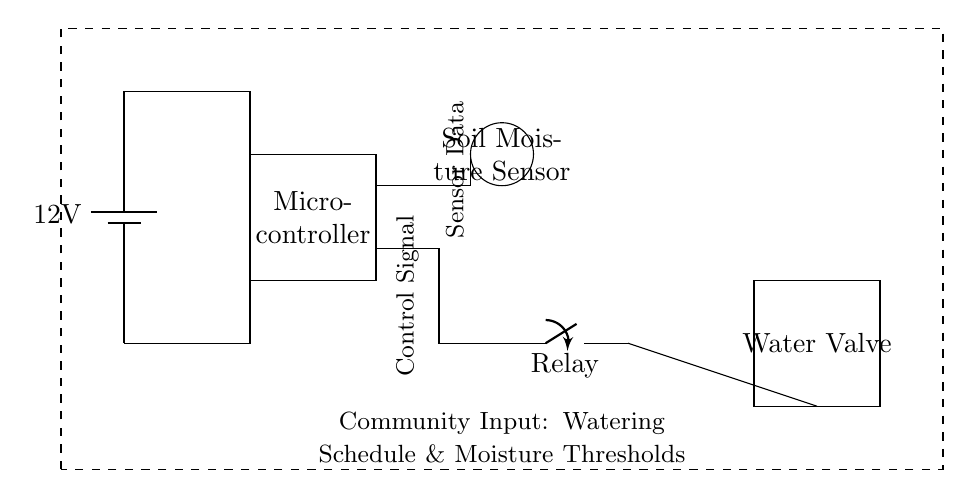What is the voltage supply in this circuit? The circuit is powered by a battery labeled with 12V, indicating the potential difference provided across the entire circuit.
Answer: 12V What component measures the soil moisture? The circular symbol in the diagram labeled "Soil Moisture Sensor" is responsible for measuring the soil's water content.
Answer: Soil Moisture Sensor What does the relay control in the circuit? The relay, marked in the diagram, controls the operation of the water valve, allowing water to flow based on the control signal from the microcontroller.
Answer: Water Valve How does the microcontroller receive data? The microcontroller is connected to the soil moisture sensor through a labeled connection for sensor data, allowing it to receive moisture readings for processing.
Answer: Sensor Data What triggers the operation of the water valve? The control signal from the microcontroller activates the relay, which in turn opens or closes the water valve based on moisture levels detected by the sensor.
Answer: Control Signal What is the purpose of the dashed rectangle in the diagram? The dashed rectangle represents the area for community input, indicating a feedback mechanism for setting the watering schedule and moisture thresholds based on community needs.
Answer: Community Input 